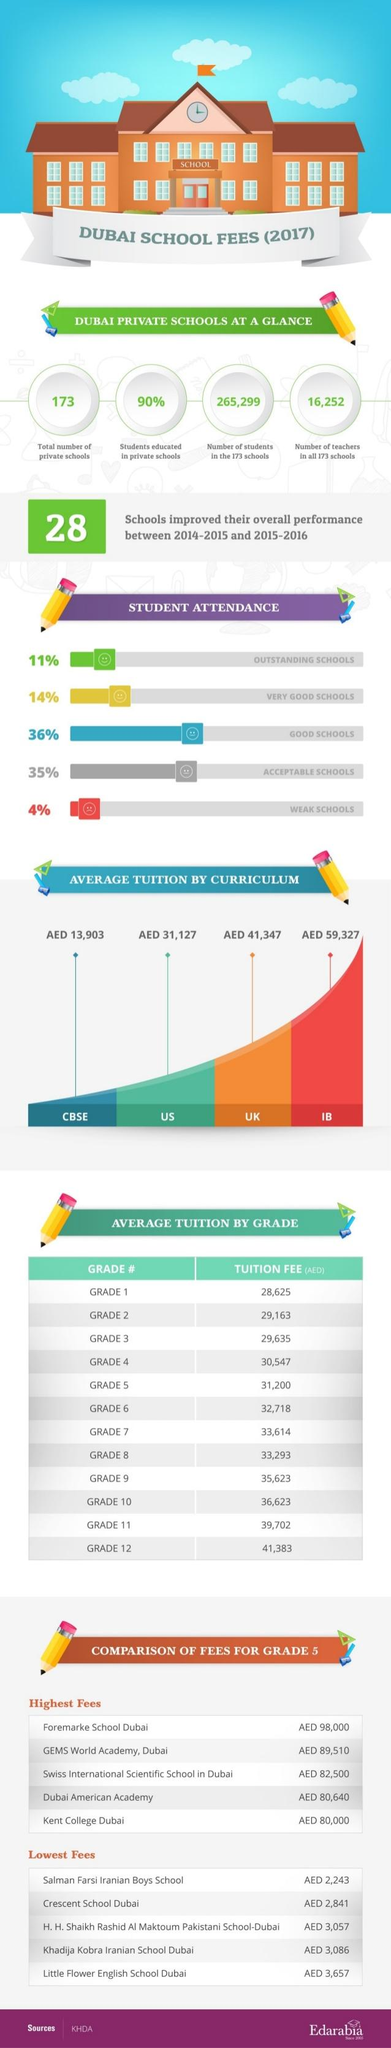Outline some significant characteristics in this image. There are a total of 265,299 students studying in private schools. The tuition fee is more than 30,000 for at least 9 grades. The inverse of student attendance for very good schools is 86 percent. Crescent School Dubai has the second lowest fees for grade 5 among all the schools in Dubai. The average tuition fee for UK curriculum is AED 41,347. 